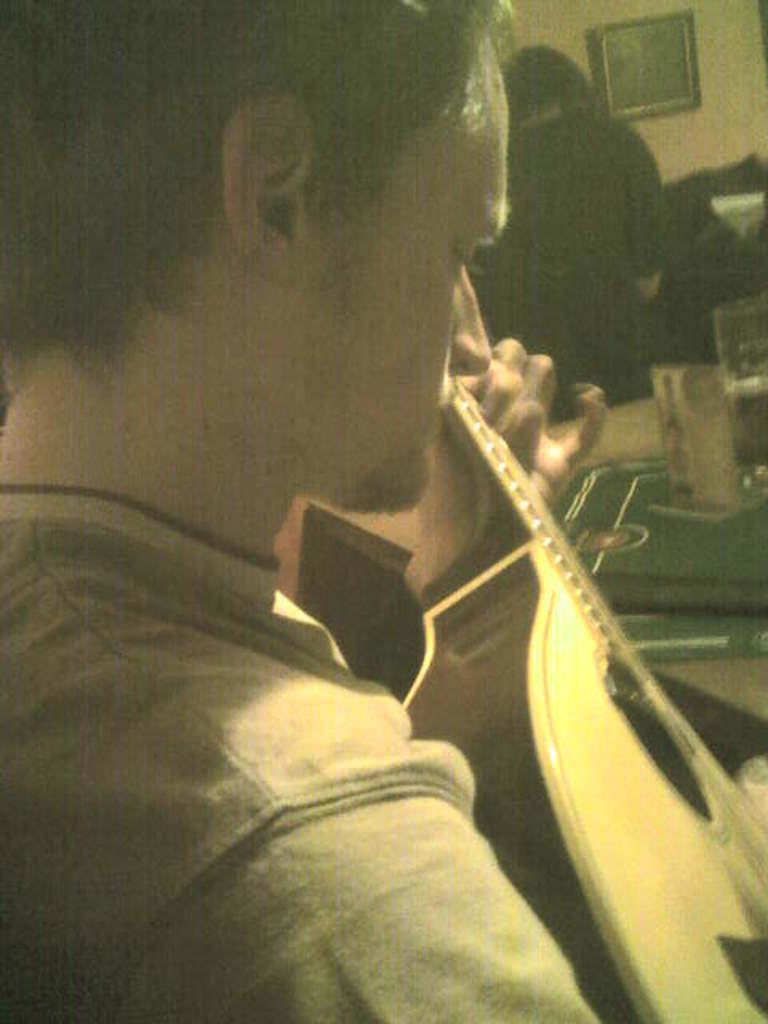What is the man in the image holding? The man is holding a guitar in the image. What can be seen on the table in the image? There is a glass on the table in the image, along with other objects. What is on the wall in the image? There is a frame on the wall in the image. Can you describe the person in the background of the image? There is a person standing in the background of the image. How does the guitar grip the fact in the image? The guitar does not grip a fact in the image; it is an inanimate object and cannot hold or interact with abstract concepts like facts. 